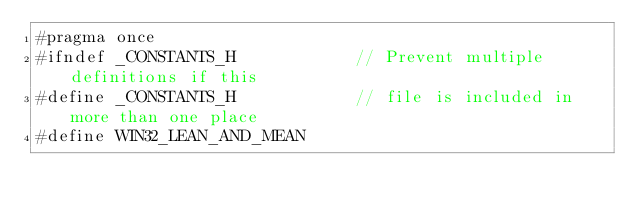Convert code to text. <code><loc_0><loc_0><loc_500><loc_500><_C_>#pragma once
#ifndef _CONSTANTS_H            // Prevent multiple definitions if this
#define _CONSTANTS_H            // file is included in more than one place
#define WIN32_LEAN_AND_MEAN
</code> 